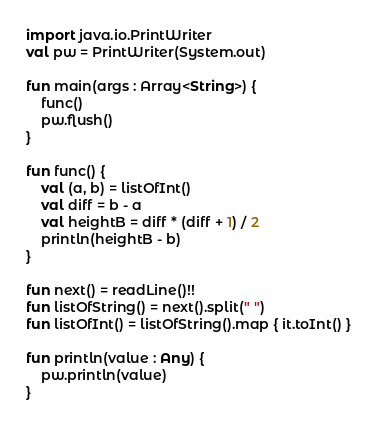<code> <loc_0><loc_0><loc_500><loc_500><_Kotlin_>import java.io.PrintWriter
val pw = PrintWriter(System.out)

fun main(args : Array<String>) {
    func()
    pw.flush()
}

fun func() {
    val (a, b) = listOfInt()
    val diff = b - a
    val heightB = diff * (diff + 1) / 2
    println(heightB - b)
}

fun next() = readLine()!!
fun listOfString() = next().split(" ")
fun listOfInt() = listOfString().map { it.toInt() }

fun println(value : Any) {
    pw.println(value)
}</code> 